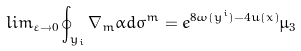<formula> <loc_0><loc_0><loc_500><loc_500>l i m _ { \varepsilon \rightarrow 0 } \oint _ { y _ { i } } \nabla _ { m } \alpha d \sigma ^ { m } = e ^ { 8 \omega ( y ^ { i } ) - 4 u ( x ) } \mu _ { 3 }</formula> 